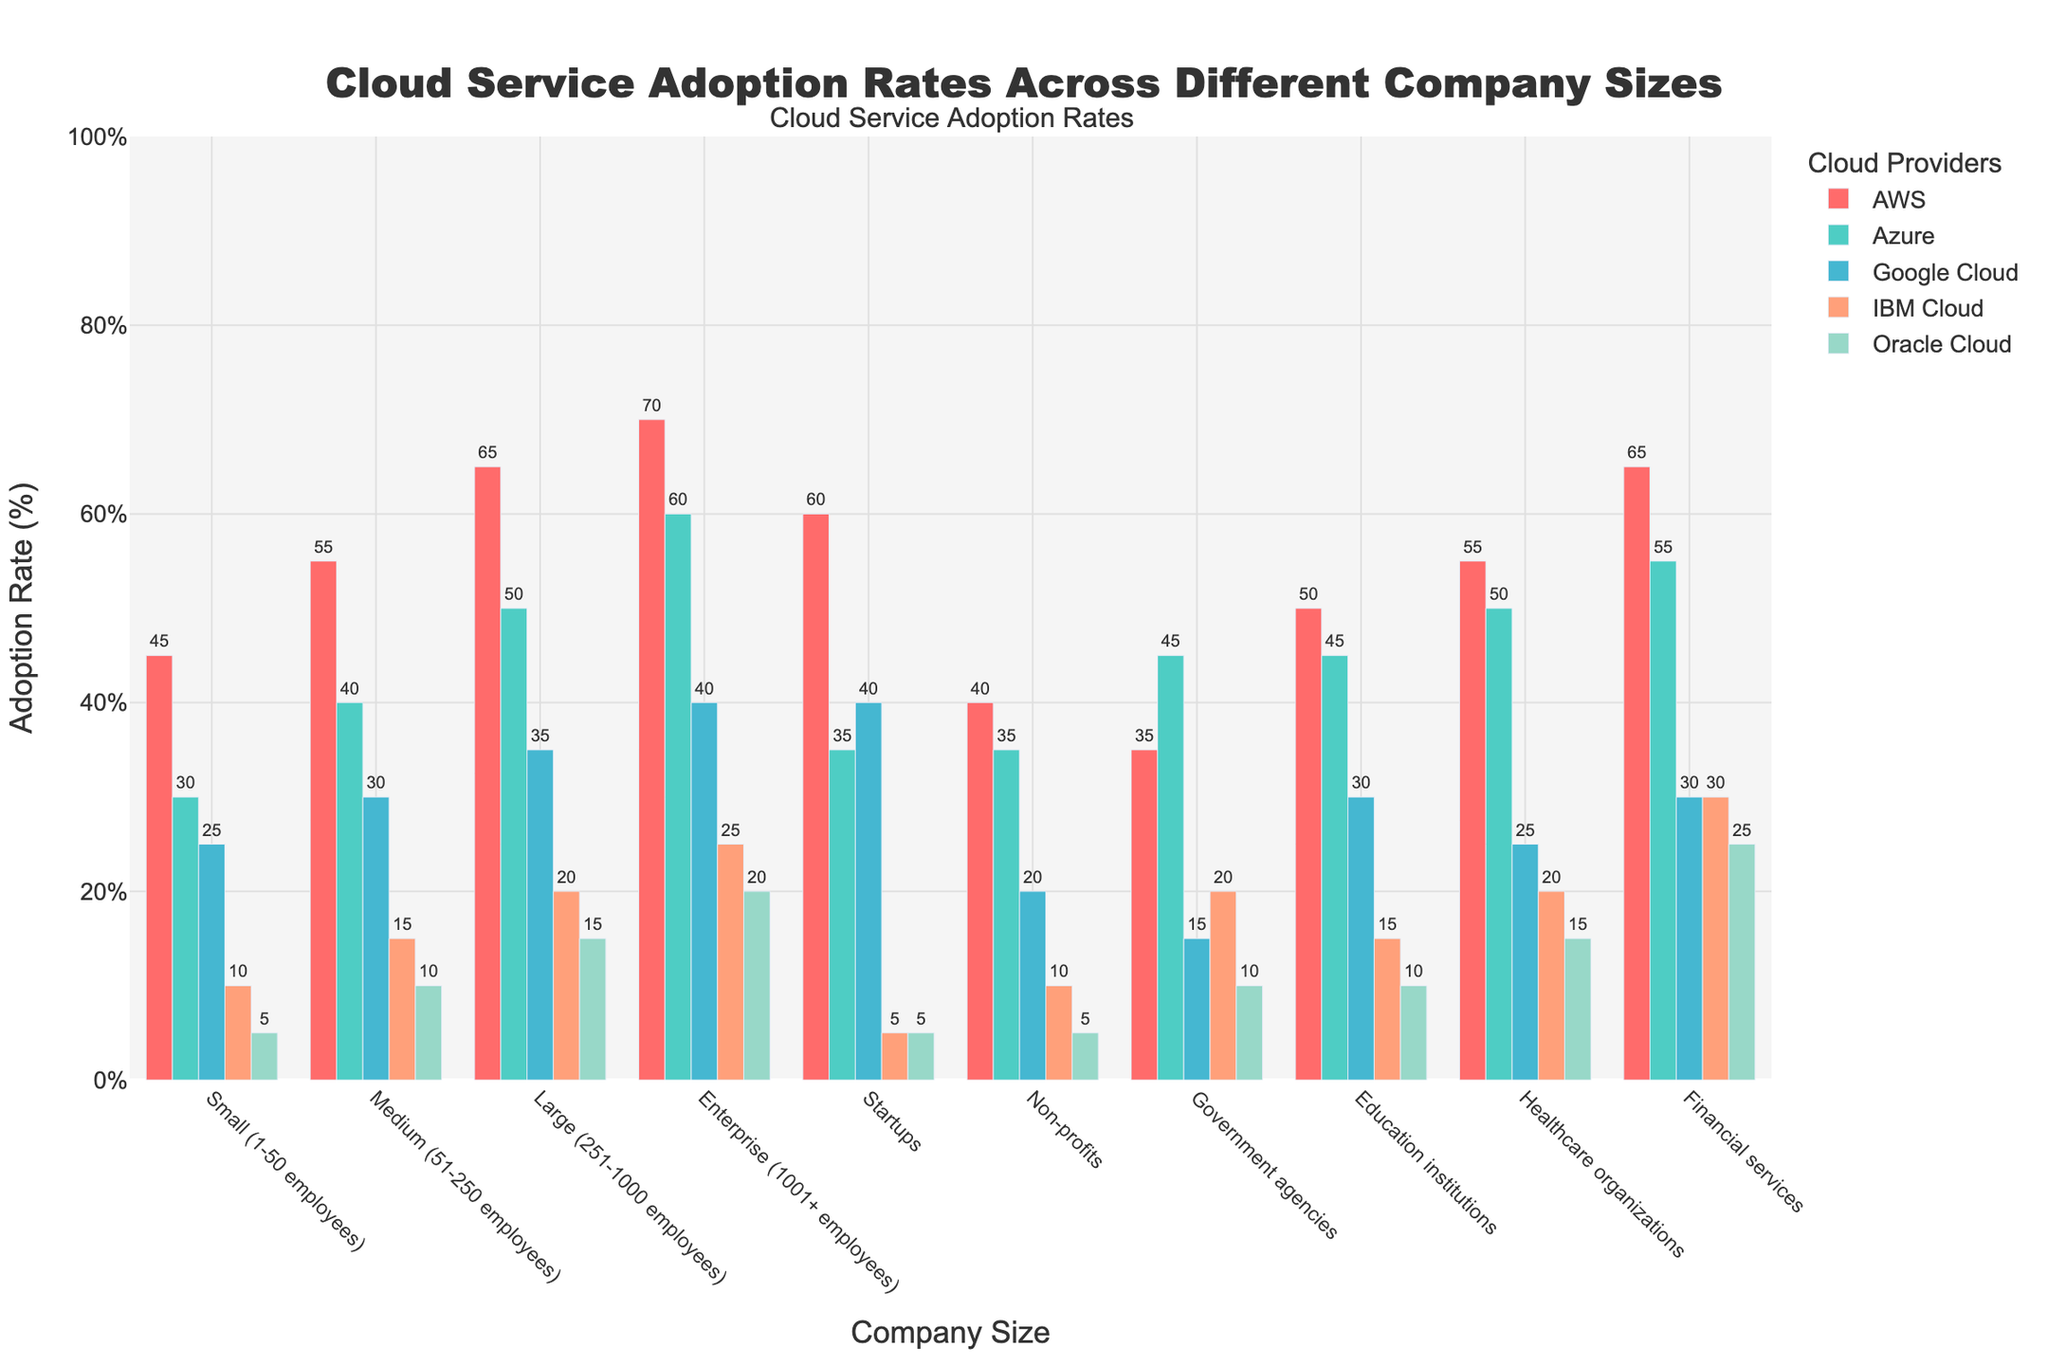What's the most popular cloud service provider among enterprise companies? The tallest bar in the "Enterprise (1001+ employees)" category represents AWS, indicating it has the highest adoption rate.
Answer: AWS Which company size shows the highest adoption rate for Google Cloud? The tallest bar for Google Cloud is in the "Startups" category, indicating they have the highest adoption rate for Google Cloud.
Answer: Startups What is the total adoption rate for Azure across all company sizes? Summing up the adoption rates of Azure across all company sizes: 30 + 40 + 50 + 60 + 35 + 35 + 45 + 45 + 50 + 55 = 445%.
Answer: 445% Compare the adoption rates of AWS and IBM Cloud in large companies. Which one is higher and by how much? For large companies, AWS has an adoption rate of 65% and IBM Cloud has an adoption rate of 20%. The difference is 65% - 20% = 45%.
Answer: AWS, by 45% What is the average adoption rate of Oracle Cloud across all company sizes? Sum the adoption rates of Oracle Cloud and divide by the number of categories: (5 + 10 + 15 + 20 + 5 + 5 + 10 + 10 + 15 + 25) / 10 = 120 / 10 = 12%.
Answer: 12% Which cloud service provider has the lowest adoption rate among government agencies? The shortest bar in the "Government agencies" category represents Google Cloud, indicating it has the lowest adoption rate.
Answer: Google Cloud How does the adoption rate of AWS in healthcare organizations compare to that in financial services? The adoption rate of AWS in healthcare organizations is 55%, while in financial services it is 65%. AWS adoption in financial services is higher by 10%.
Answer: Financial services, by 10% What is the difference in adoption rates between the highest and lowest cloud providers for small companies? For small companies, the adoption rates are: AWS 45%, Azure 30%, Google Cloud 25%, IBM Cloud 10%, Oracle Cloud 5%. The difference is 45% - 5% = 40%.
Answer: 40% What is the median adoption rate for Azure across all company sizes? Listing the Azure rates in ascending order: 30, 35, 35, 40, 45, 45, 50, 50, 55, 60. The median is the average of the 5th and 6th values: (45 + 45) / 2 = 45%.
Answer: 45% Visualizing the colors used in the chart, which cloud provider is represented by the green bar? Observing the green bar in the chart, it represents Azure.
Answer: Azure 